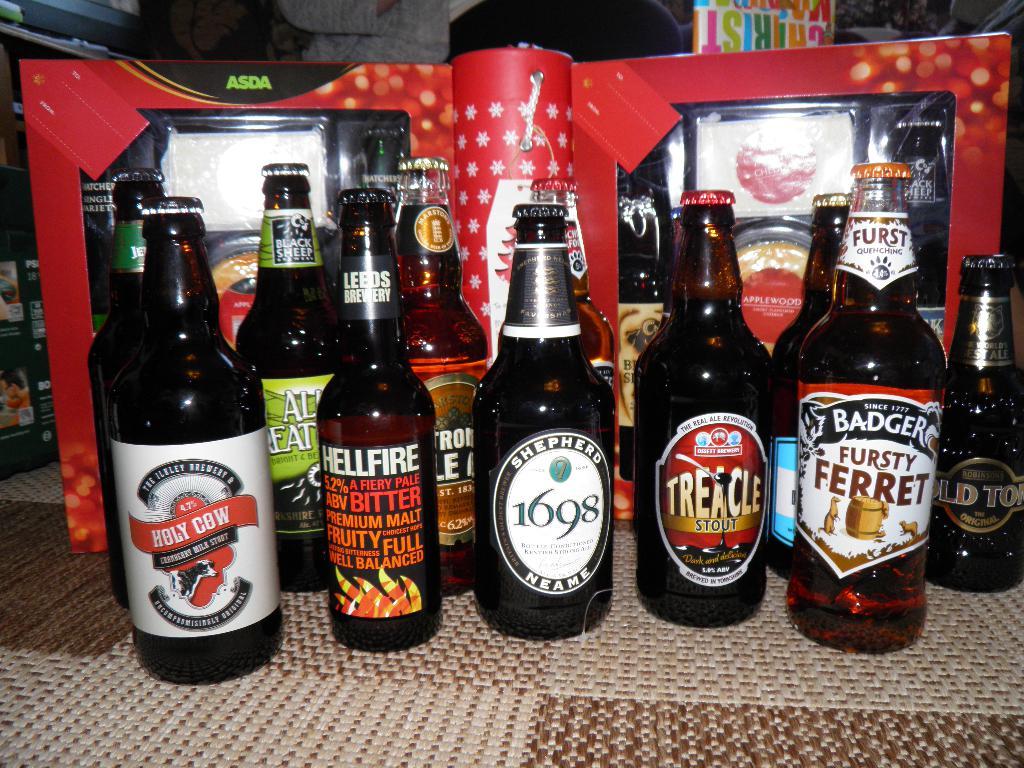Who make the fursty ferret flavored beer?
Ensure brevity in your answer.  Badger. What year did shephard beer come about?
Your answer should be compact. 1698. 